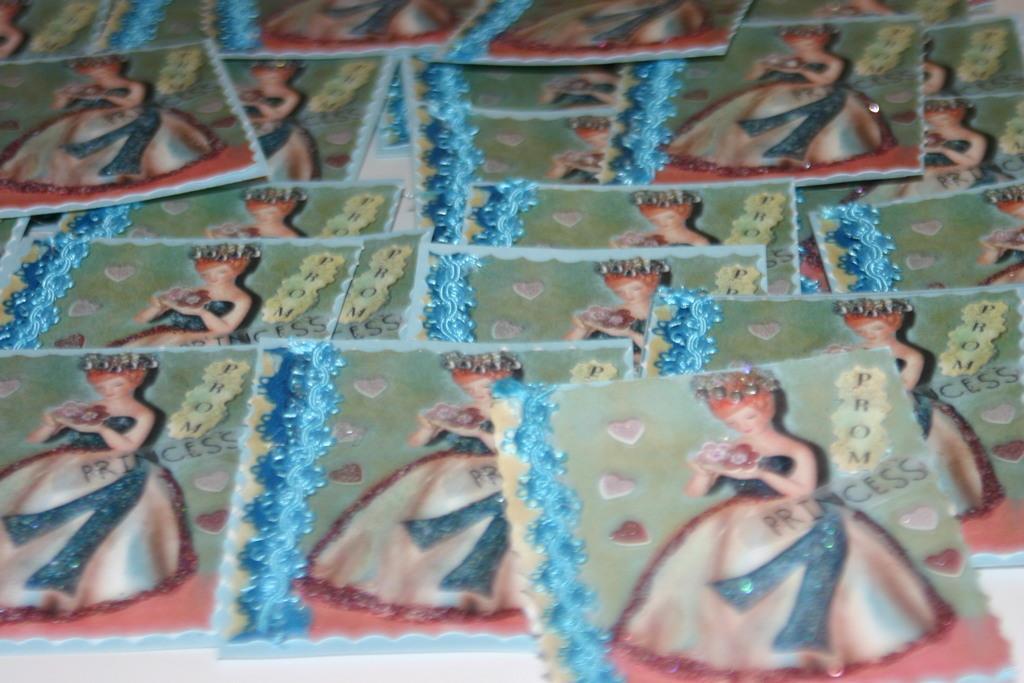Please provide a concise description of this image. In this image, we can see some photos. 